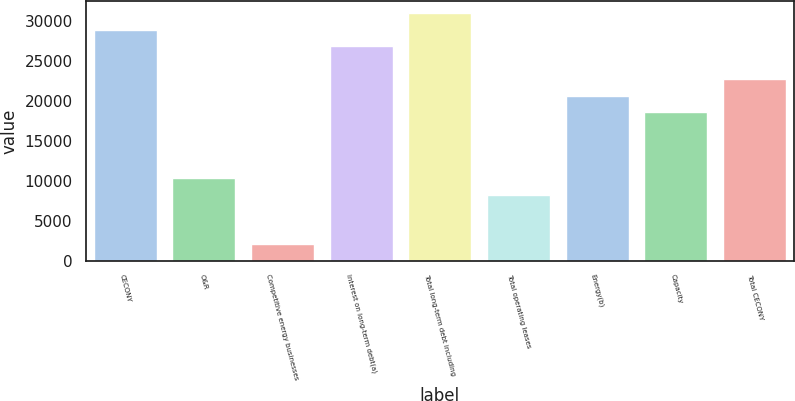Convert chart. <chart><loc_0><loc_0><loc_500><loc_500><bar_chart><fcel>CECONY<fcel>O&R<fcel>Competitive energy businesses<fcel>Interest on long-term debt(a)<fcel>Total long-term debt including<fcel>Total operating leases<fcel>Energy(b)<fcel>Capacity<fcel>Total CECONY<nl><fcel>28855.6<fcel>10307.5<fcel>2063.9<fcel>26794.7<fcel>30916.5<fcel>8246.6<fcel>20612<fcel>18551.1<fcel>22672.9<nl></chart> 